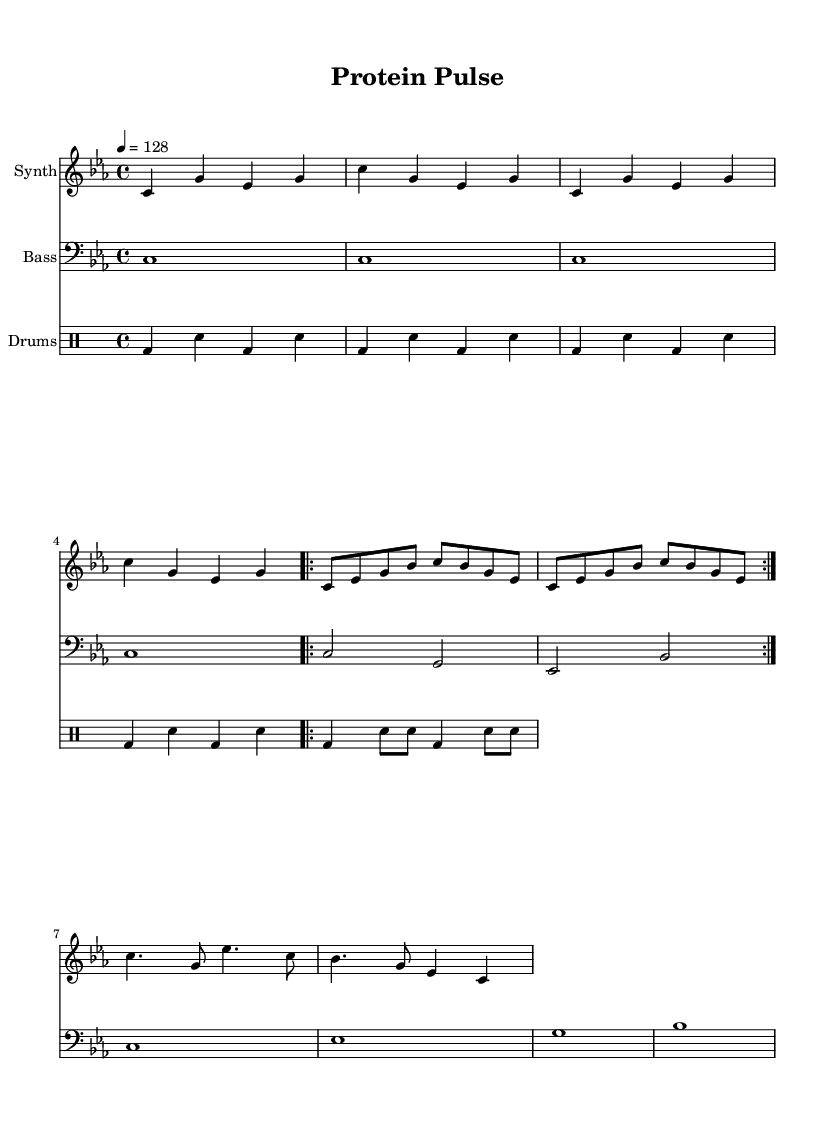What is the key signature of this music? The key signature is C minor, which has five flats (B♭, E♭, A♭, D♭, G♭). This can be determined by looking at the key signature indicator at the beginning of the score.
Answer: C minor What is the time signature of the piece? The time signature is 4/4, shown at the beginning of the score, indicating there are four beats per measure, and the quarter note gets one beat.
Answer: 4/4 What is the tempo marking of this music? The tempo marking is 128 beats per minute, indicated by "4 = 128" at the beginning of the score. This tells performers how fast the piece should be played.
Answer: 128 How many measures are in the synth verse section? The synth verse section contains 8 measures. By examining the synth verse notation, we can see it is marked to repeat twice, and each iteration has 4 measures.
Answer: 8 What rhythmic pattern is used in the drum intro? The drum intro uses a pattern of bass drum and snare drum, alternating in a specific sequence over two measures, shown in the drummode notation.
Answer: Bass and snare How many notes are in the synth chorus? The synth chorus has 8 notes. By counting the individual notes in the chorus section of the synth staff, we can confirm the total number of notes.
Answer: 8 Which instrument plays the bass intro? The bass intro is played by the instrument labeled "Bass" in the score, which is specified with a bass clef underneath the notation.
Answer: Bass 